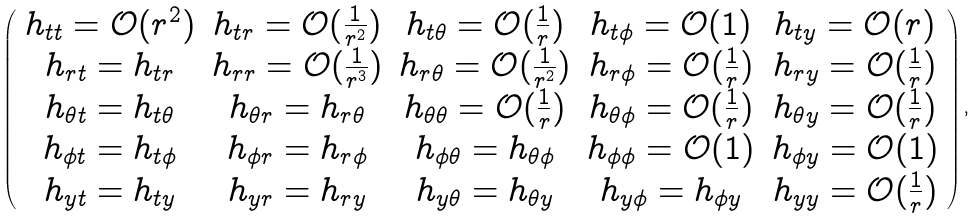<formula> <loc_0><loc_0><loc_500><loc_500>\left ( \begin{array} { c c c c c } h _ { t t } = \mathcal { O } ( r ^ { 2 } ) & h _ { t r } = \mathcal { O } ( \frac { 1 } { r ^ { 2 } } ) & h _ { t \theta } = \mathcal { O } ( \frac { 1 } { r } ) & h _ { t \phi } = \mathcal { O } ( 1 ) & h _ { t y } = \mathcal { O } ( r ) \\ h _ { r t } = h _ { t r } & h _ { r r } = \mathcal { O } ( \frac { 1 } { r ^ { 3 } } ) & h _ { r \theta } = \mathcal { O } ( \frac { 1 } { r ^ { 2 } } ) & h _ { r \phi } = \mathcal { O } ( \frac { 1 } { r } ) & h _ { r y } = \mathcal { O } ( \frac { 1 } { r } ) \\ h _ { \theta t } = h _ { t \theta } & h _ { \theta r } = h _ { r \theta } & h _ { \theta \theta } = \mathcal { O } ( \frac { 1 } { r } ) & h _ { \theta \phi } = \mathcal { O } ( \frac { 1 } { r } ) & h _ { \theta y } = \mathcal { O } ( \frac { 1 } { r } ) \\ h _ { \phi t } = h _ { t \phi } & h _ { \phi r } = h _ { r \phi } & h _ { \phi \theta } = h _ { \theta \phi } & h _ { \phi \phi } = \mathcal { O } ( 1 ) & h _ { \phi y } = \mathcal { O } ( 1 ) \\ h _ { y t } = h _ { t y } & h _ { y r } = h _ { r y } & h _ { y \theta } = h _ { \theta y } & h _ { y \phi } = h _ { \phi y } & h _ { y y } = \mathcal { O } ( \frac { 1 } { r } ) \end{array} \right ) ,</formula> 